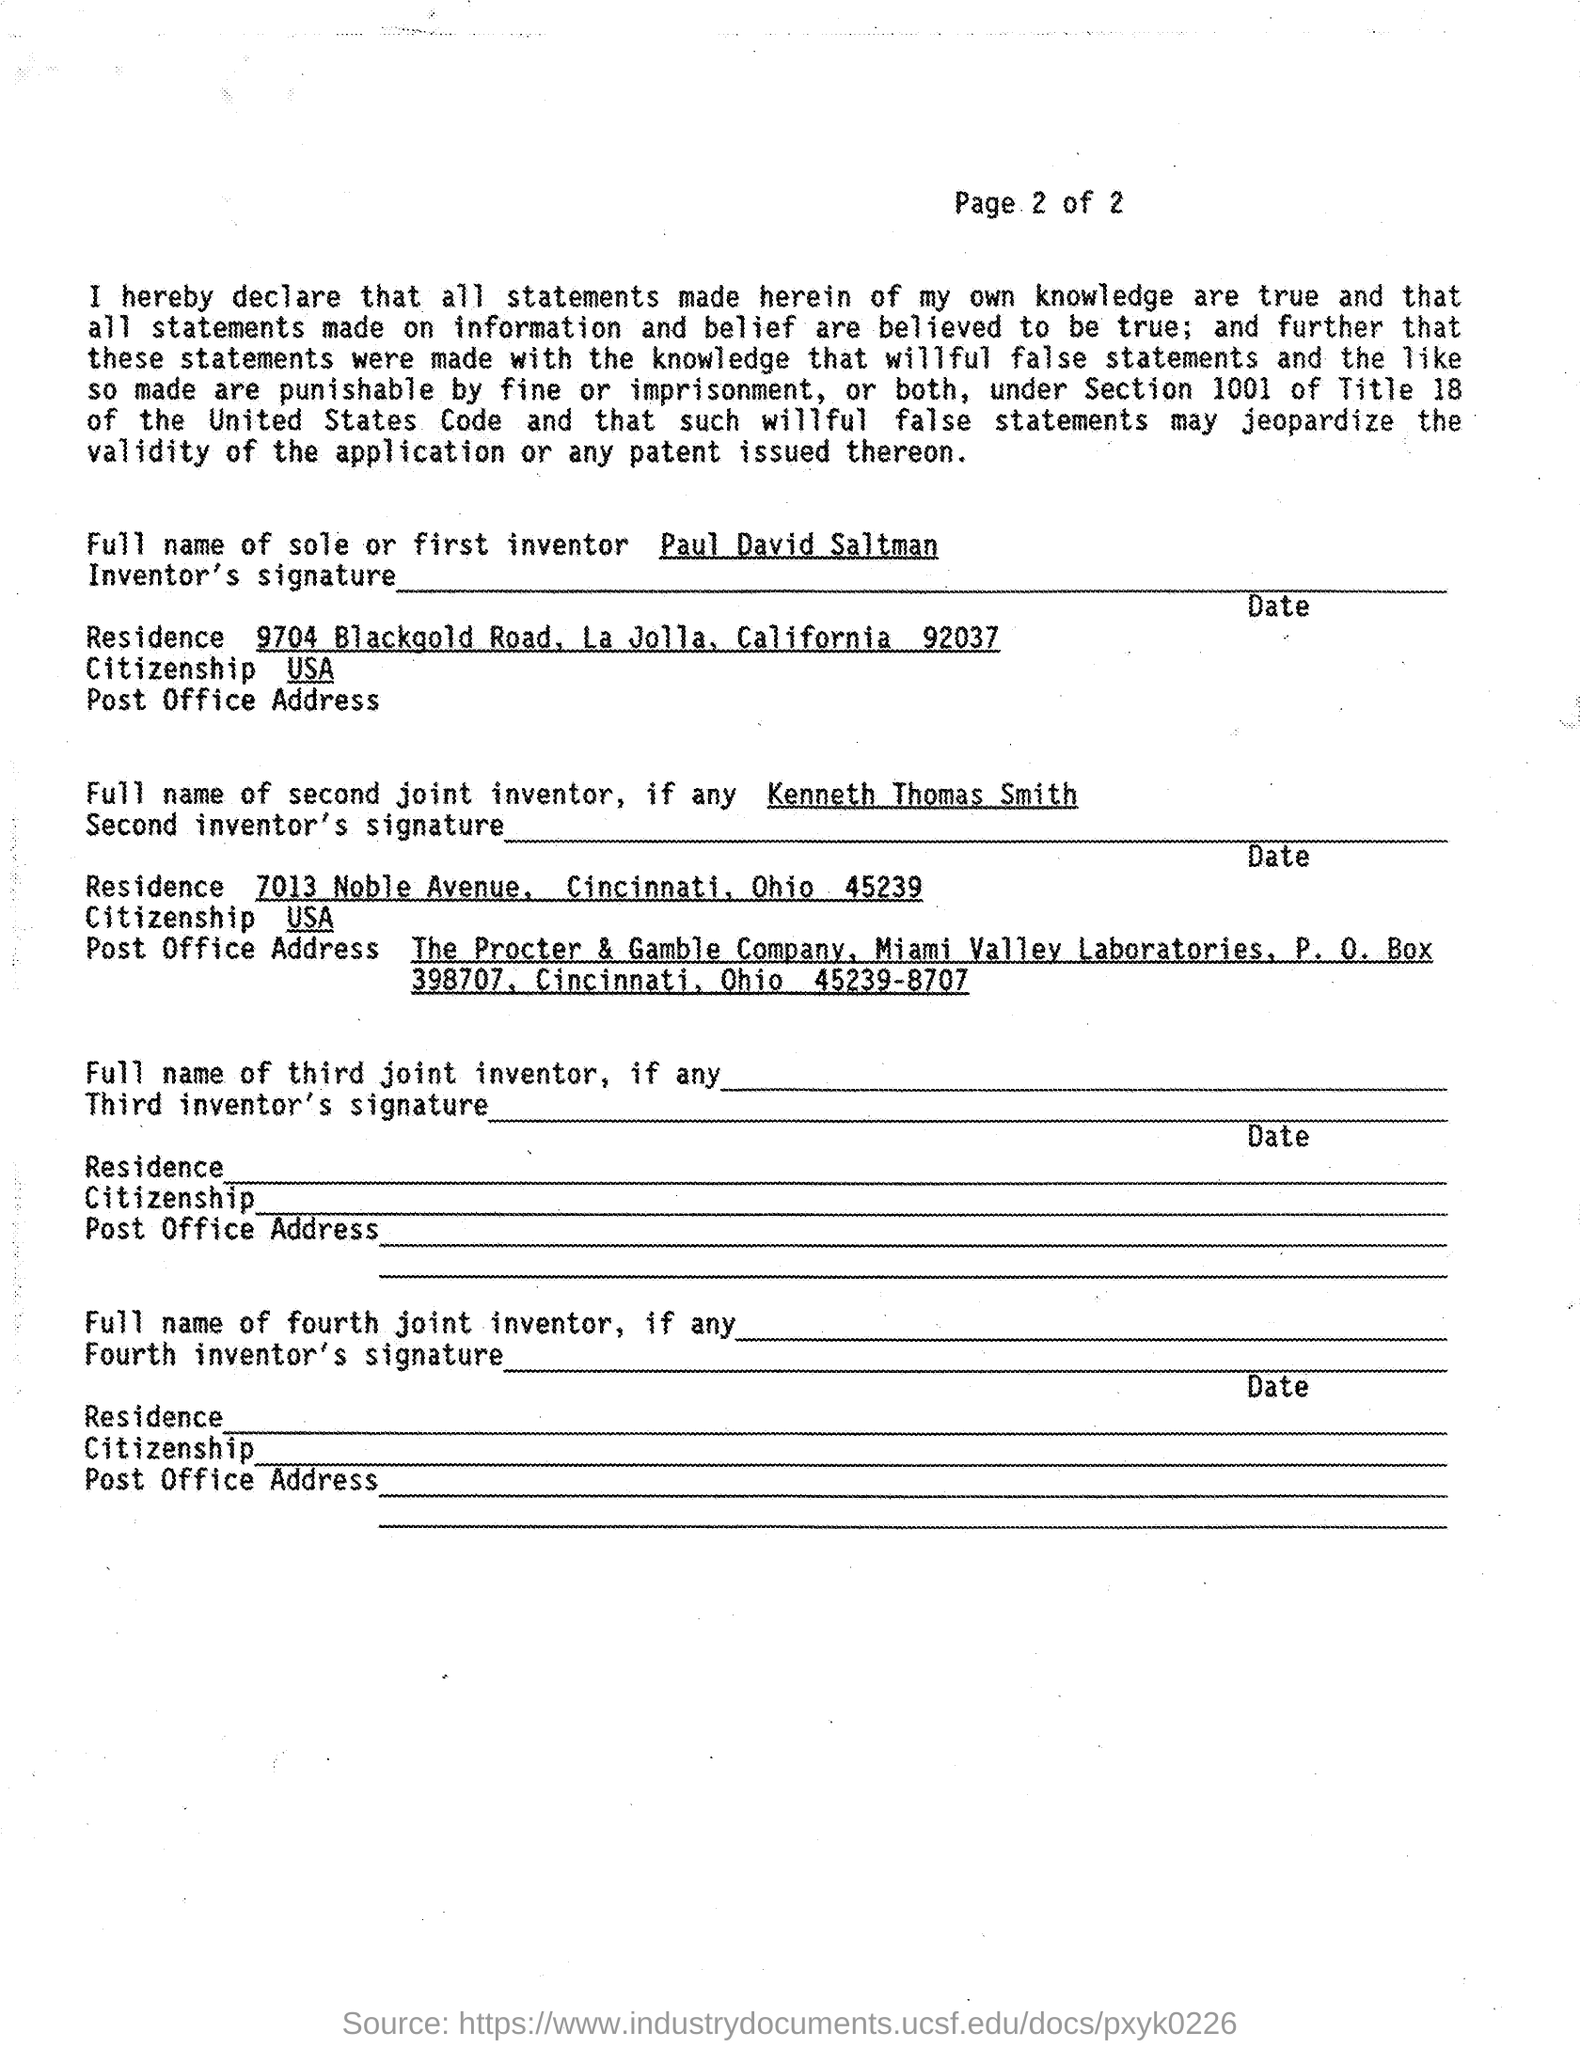Who is the first inventor?
Your response must be concise. Paul David Saltman. 